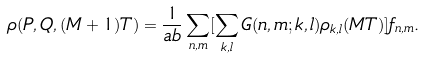Convert formula to latex. <formula><loc_0><loc_0><loc_500><loc_500>\rho ( P , Q , ( M + 1 ) T ) = \frac { 1 } { a b } \sum _ { n , m } [ \sum _ { k , l } G ( n , m ; k , l ) \rho _ { k , l } ( M T ) ] f _ { n , m } .</formula> 